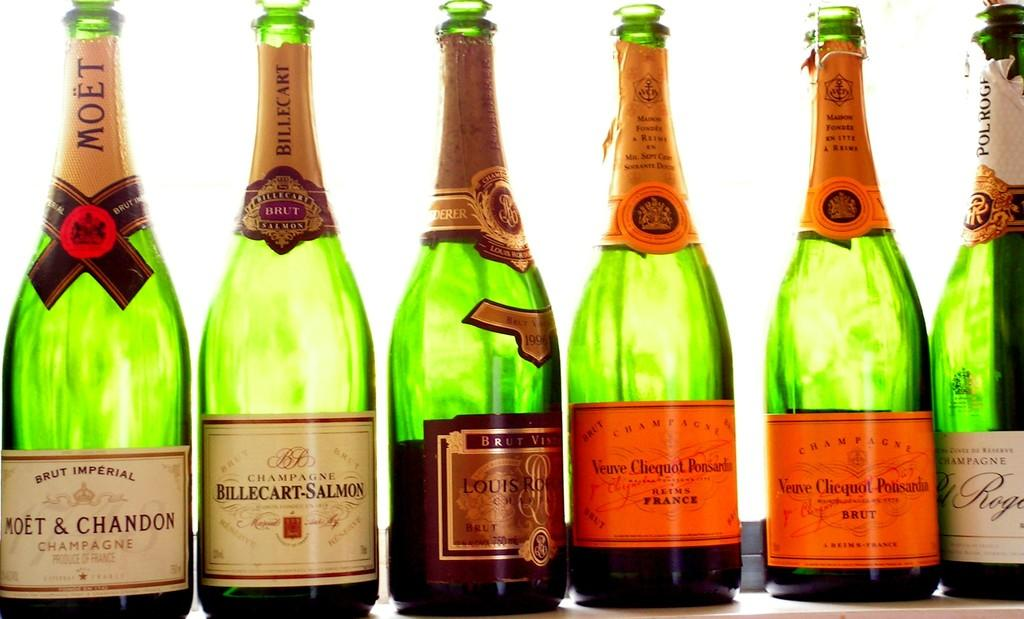<image>
Relay a brief, clear account of the picture shown. several bottles of champagne by moet & chandon 